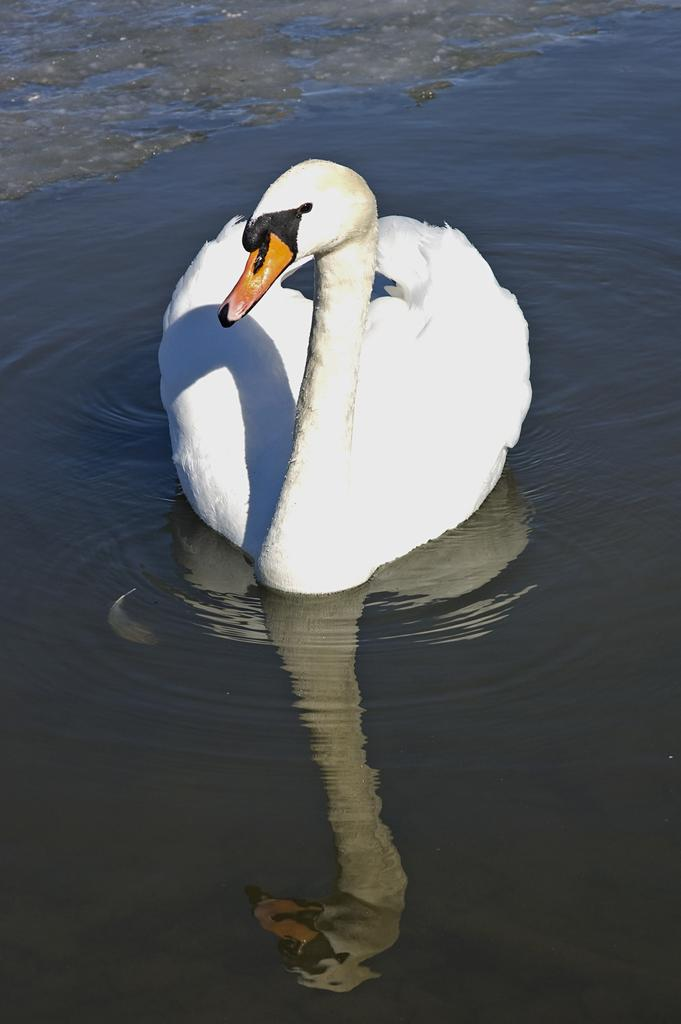What type of animal is in the image? There is a white swan in the image. Where is the swan located? The swan is on the water. What type of silk material is draped over the chair in the image? There is no chair or silk material present in the image; it features a white swan on the water. 